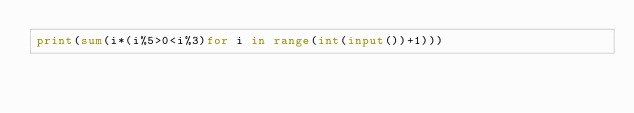<code> <loc_0><loc_0><loc_500><loc_500><_Python_>print(sum(i*(i%5>0<i%3)for i in range(int(input())+1)))</code> 